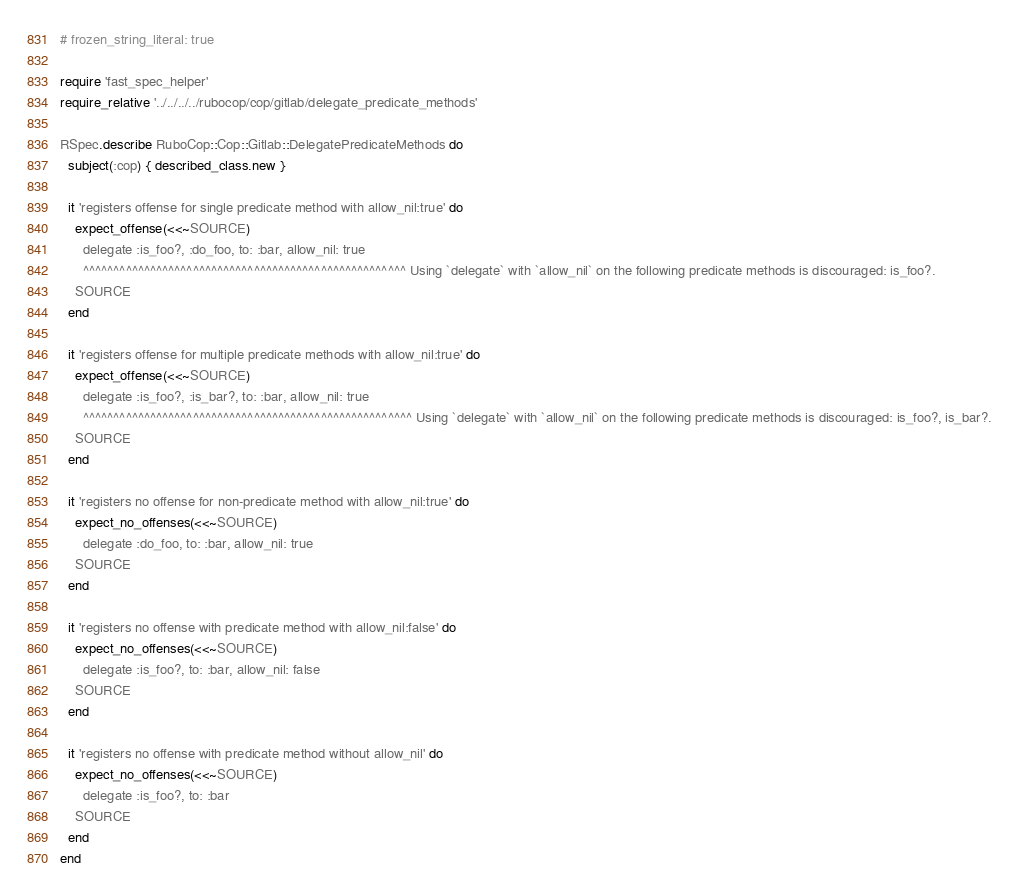<code> <loc_0><loc_0><loc_500><loc_500><_Ruby_># frozen_string_literal: true

require 'fast_spec_helper'
require_relative '../../../../rubocop/cop/gitlab/delegate_predicate_methods'

RSpec.describe RuboCop::Cop::Gitlab::DelegatePredicateMethods do
  subject(:cop) { described_class.new }

  it 'registers offense for single predicate method with allow_nil:true' do
    expect_offense(<<~SOURCE)
      delegate :is_foo?, :do_foo, to: :bar, allow_nil: true
      ^^^^^^^^^^^^^^^^^^^^^^^^^^^^^^^^^^^^^^^^^^^^^^^^^^^^^ Using `delegate` with `allow_nil` on the following predicate methods is discouraged: is_foo?.
    SOURCE
  end

  it 'registers offense for multiple predicate methods with allow_nil:true' do
    expect_offense(<<~SOURCE)
      delegate :is_foo?, :is_bar?, to: :bar, allow_nil: true
      ^^^^^^^^^^^^^^^^^^^^^^^^^^^^^^^^^^^^^^^^^^^^^^^^^^^^^^ Using `delegate` with `allow_nil` on the following predicate methods is discouraged: is_foo?, is_bar?.
    SOURCE
  end

  it 'registers no offense for non-predicate method with allow_nil:true' do
    expect_no_offenses(<<~SOURCE)
      delegate :do_foo, to: :bar, allow_nil: true
    SOURCE
  end

  it 'registers no offense with predicate method with allow_nil:false' do
    expect_no_offenses(<<~SOURCE)
      delegate :is_foo?, to: :bar, allow_nil: false
    SOURCE
  end

  it 'registers no offense with predicate method without allow_nil' do
    expect_no_offenses(<<~SOURCE)
      delegate :is_foo?, to: :bar
    SOURCE
  end
end
</code> 